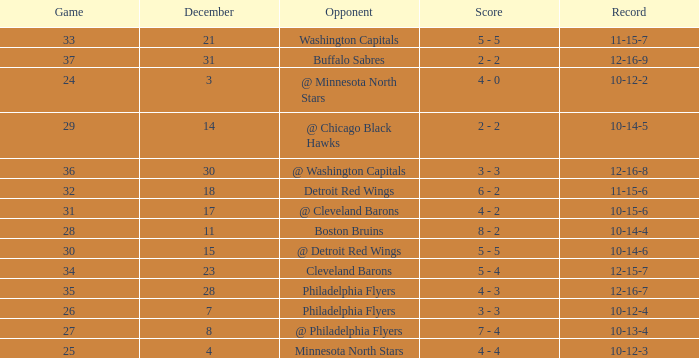What is Opponent, when Game is "37"? Buffalo Sabres. 